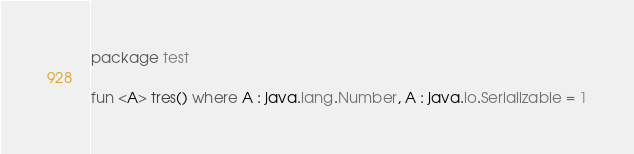Convert code to text. <code><loc_0><loc_0><loc_500><loc_500><_Kotlin_>package test

fun <A> tres() where A : java.lang.Number, A : java.io.Serializable = 1
</code> 